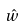Convert formula to latex. <formula><loc_0><loc_0><loc_500><loc_500>\hat { w }</formula> 